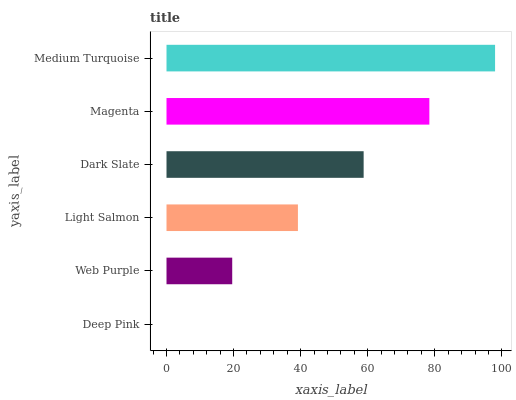Is Deep Pink the minimum?
Answer yes or no. Yes. Is Medium Turquoise the maximum?
Answer yes or no. Yes. Is Web Purple the minimum?
Answer yes or no. No. Is Web Purple the maximum?
Answer yes or no. No. Is Web Purple greater than Deep Pink?
Answer yes or no. Yes. Is Deep Pink less than Web Purple?
Answer yes or no. Yes. Is Deep Pink greater than Web Purple?
Answer yes or no. No. Is Web Purple less than Deep Pink?
Answer yes or no. No. Is Dark Slate the high median?
Answer yes or no. Yes. Is Light Salmon the low median?
Answer yes or no. Yes. Is Magenta the high median?
Answer yes or no. No. Is Deep Pink the low median?
Answer yes or no. No. 